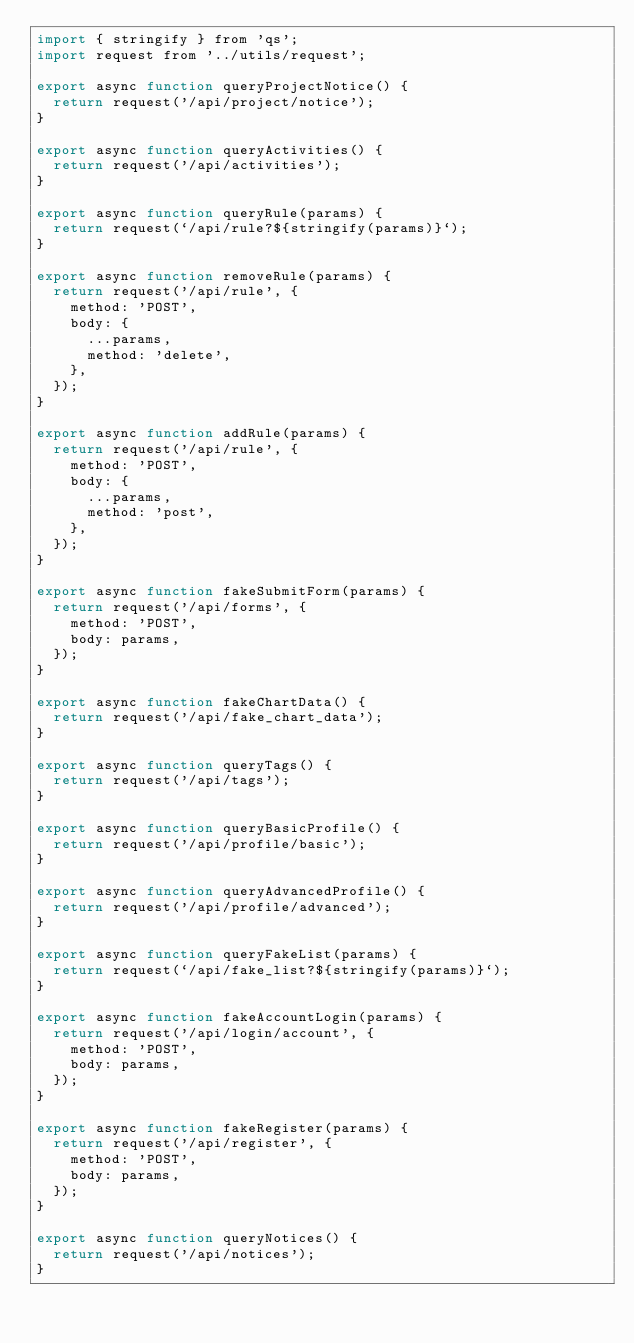<code> <loc_0><loc_0><loc_500><loc_500><_JavaScript_>import { stringify } from 'qs';
import request from '../utils/request';

export async function queryProjectNotice() {
  return request('/api/project/notice');
}

export async function queryActivities() {
  return request('/api/activities');
}

export async function queryRule(params) {
  return request(`/api/rule?${stringify(params)}`);
}

export async function removeRule(params) {
  return request('/api/rule', {
    method: 'POST',
    body: {
      ...params,
      method: 'delete',
    },
  });
}

export async function addRule(params) {
  return request('/api/rule', {
    method: 'POST',
    body: {
      ...params,
      method: 'post',
    },
  });
}

export async function fakeSubmitForm(params) {
  return request('/api/forms', {
    method: 'POST',
    body: params,
  });
}

export async function fakeChartData() {
  return request('/api/fake_chart_data');
}

export async function queryTags() {
  return request('/api/tags');
}

export async function queryBasicProfile() {
  return request('/api/profile/basic');
}

export async function queryAdvancedProfile() {
  return request('/api/profile/advanced');
}

export async function queryFakeList(params) {
  return request(`/api/fake_list?${stringify(params)}`);
}

export async function fakeAccountLogin(params) {
  return request('/api/login/account', {
    method: 'POST',
    body: params,
  });
}

export async function fakeRegister(params) {
  return request('/api/register', {
    method: 'POST',
    body: params,
  });
}

export async function queryNotices() {
  return request('/api/notices');
}</code> 